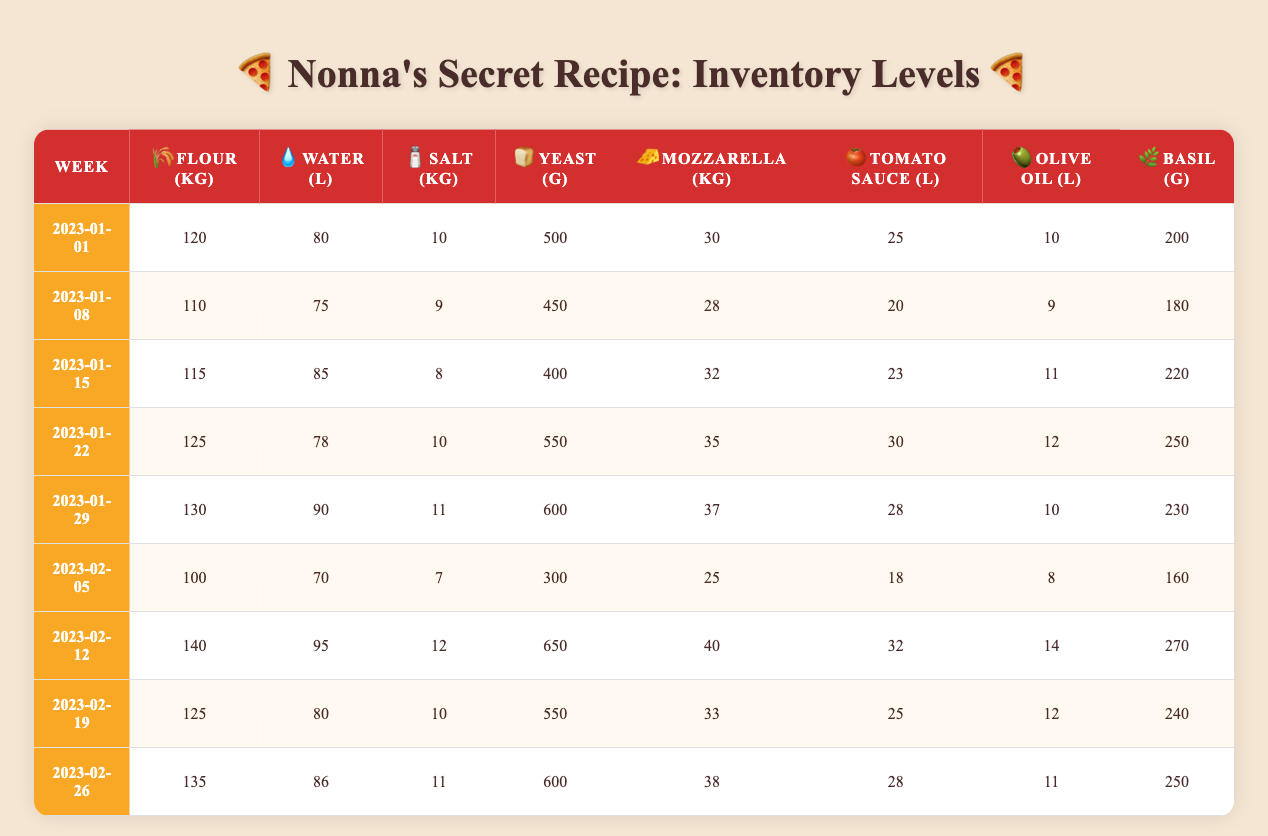What was the inventory level of mozzarella in the week of 2023-01-15? In the row for the week 2023-01-15, the inventory of mozzarella is listed as 32 kg.
Answer: 32 kg How many liters of water were available for the week of 2023-01-29? In the table, the inventory for water in the week of 2023-01-29 is shown as 90 liters.
Answer: 90 liters What week had the highest amount of flour stocked? Looking through the week entries, the highest amount of flour is found in the week of 2023-02-12, which is 140 kg.
Answer: 2023-02-12 On which week was the lowest quantity of salt recorded? The row for the week of 2023-02-05 shows the lowest salt level with 7 kg in inventory.
Answer: 7 kg What is the total amount of yeast stocked for the week of 2023-01-22? For the week of 2023-01-22, the inventory shows 550 grams of yeast.
Answer: 550 grams How much basil was available over the entire month of January in total? Summing the basil amounts from January: 200 + 180 + 220 + 250 + 230 = 1080 grams.
Answer: 1080 grams Was the amount of tomato sauce ever below 20 liters during the observed weeks? Checking the provided entries, the values for tomato sauce do not drop below 20 liters; the lowest recorded is 18 liters in the week of 2023-02-05, which confirms it's true.
Answer: Yes What is the average weekly amount of olive oil stocked throughout February? The total olive oil for February is calculated by adding 14 + 12 + 11 = 37 liters, then dividing by the 4 weeks gives an average of 37/4 = 9.25 liters.
Answer: 9.25 liters Which week had a higher amount of tomato sauce: 2023-01-22 or 2023-02-12? The inventory level of tomato sauce in week 2023-01-22 is 30 liters, while in week 2023-02-12 it is 32 liters. Since 32 liters is greater than 30 liters, so February 12 has more.
Answer: 2023-02-12 How much flour was used from the week of 2023-01-01 to 2023-01-15? To find the used flour, subtract the remaining stock from the initial stock: 120 kg (2023-01-01) - 115 kg (2023-01-15) = 5 kg.
Answer: 5 kg 